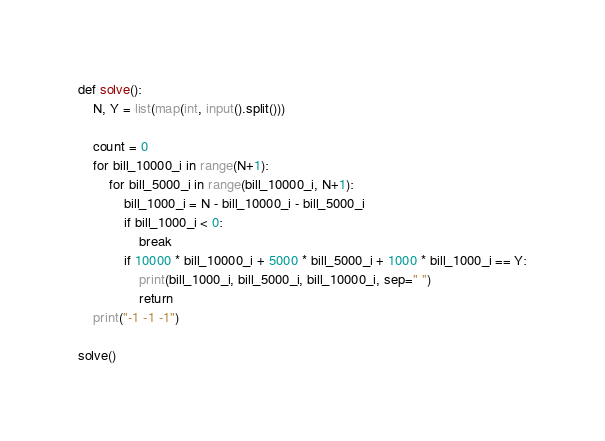<code> <loc_0><loc_0><loc_500><loc_500><_Python_>def solve():
    N, Y = list(map(int, input().split()))

    count = 0
    for bill_10000_i in range(N+1):
        for bill_5000_i in range(bill_10000_i, N+1):
            bill_1000_i = N - bill_10000_i - bill_5000_i
            if bill_1000_i < 0:
                break
            if 10000 * bill_10000_i + 5000 * bill_5000_i + 1000 * bill_1000_i == Y:
                print(bill_1000_i, bill_5000_i, bill_10000_i, sep=" ")
                return
    print("-1 -1 -1")

solve()</code> 